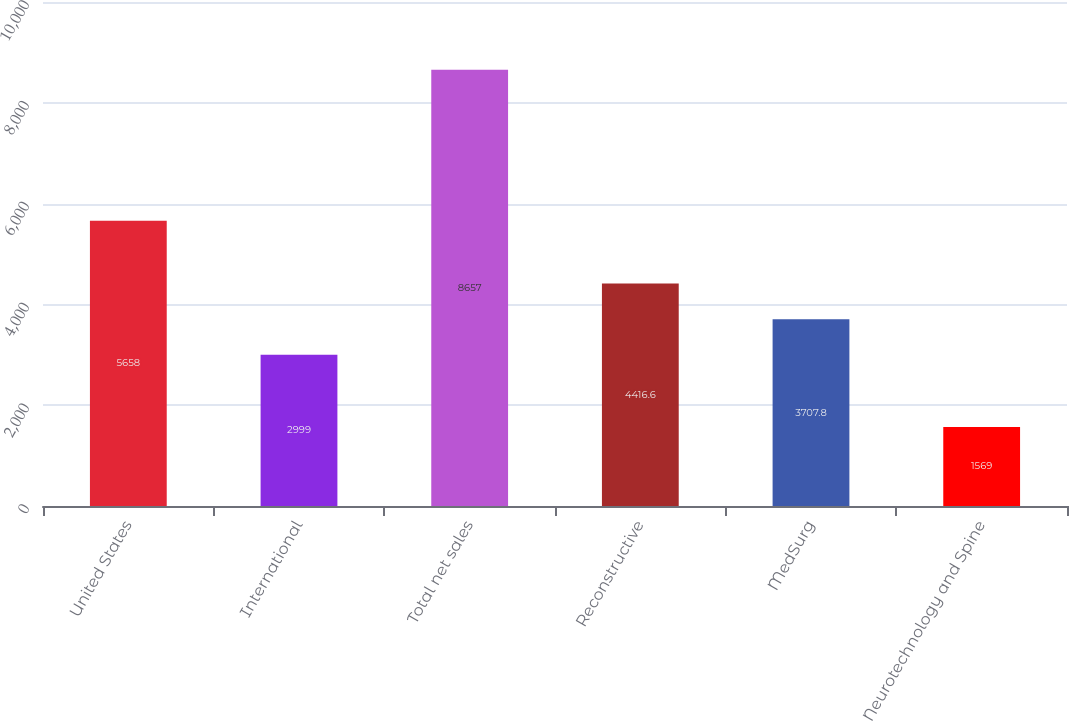Convert chart. <chart><loc_0><loc_0><loc_500><loc_500><bar_chart><fcel>United States<fcel>International<fcel>Total net sales<fcel>Reconstructive<fcel>MedSurg<fcel>Neurotechnology and Spine<nl><fcel>5658<fcel>2999<fcel>8657<fcel>4416.6<fcel>3707.8<fcel>1569<nl></chart> 